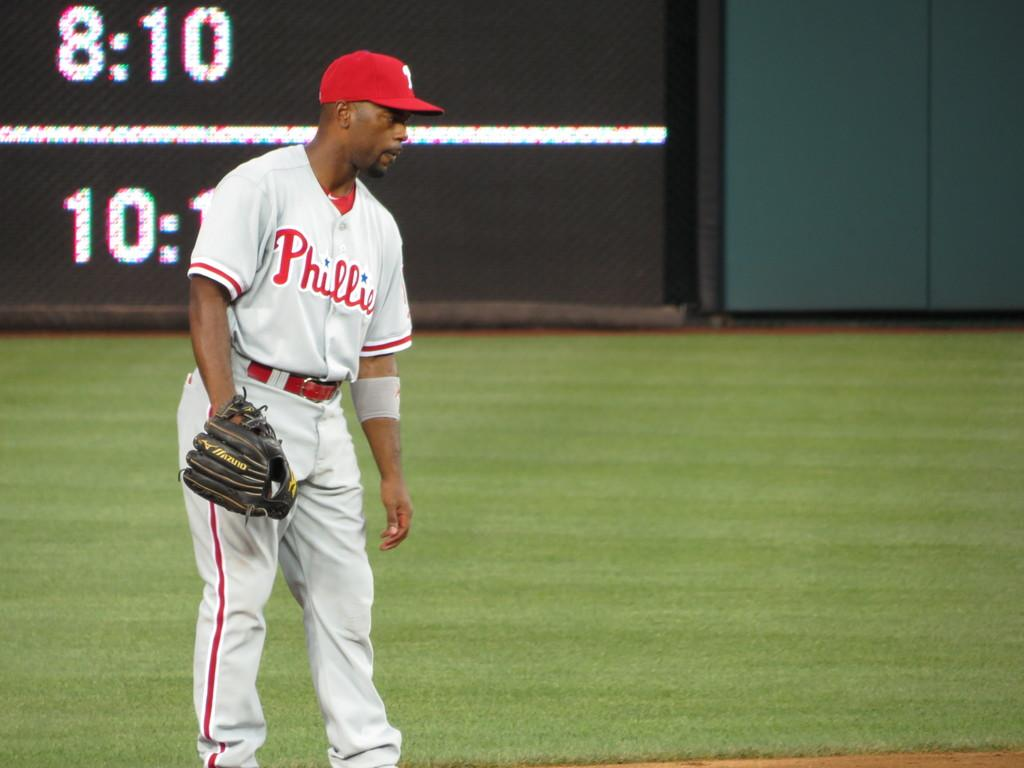<image>
Provide a brief description of the given image. A baseball player wearing a Phillies jersey stands in the middle of the field. 